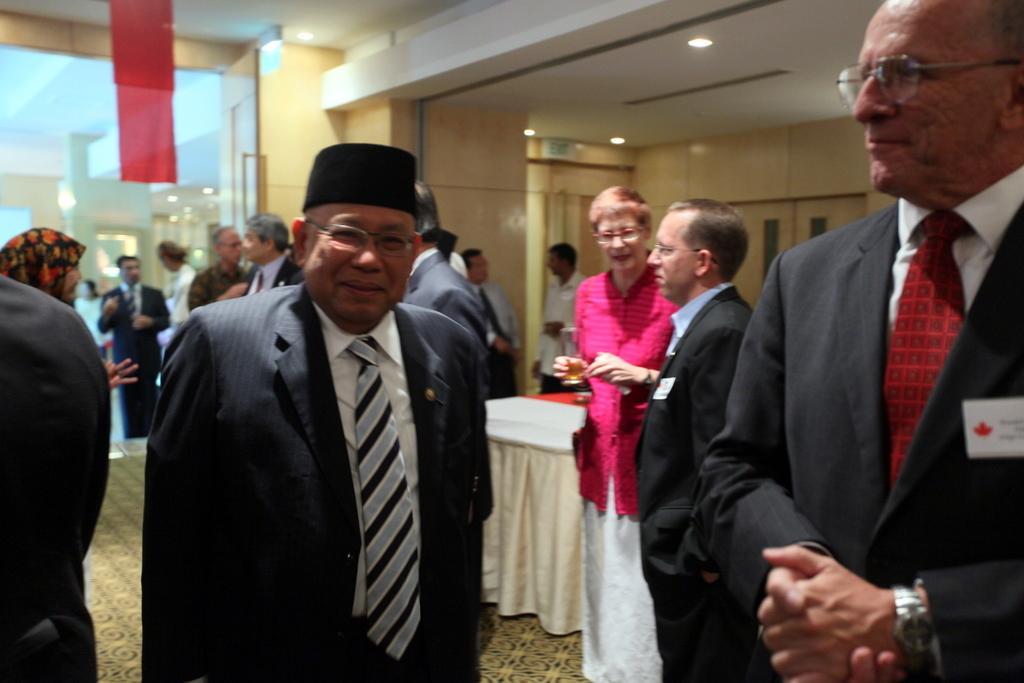In one or two sentences, can you explain what this image depicts? In this image we can see there are a few people standing on the floor, in the middle of them there is a table. At the top there is a ceiling. In the background there is a glass door. 